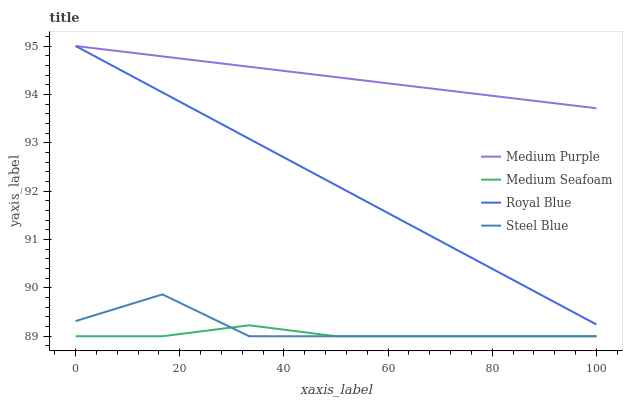Does Medium Seafoam have the minimum area under the curve?
Answer yes or no. Yes. Does Medium Purple have the maximum area under the curve?
Answer yes or no. Yes. Does Royal Blue have the minimum area under the curve?
Answer yes or no. No. Does Royal Blue have the maximum area under the curve?
Answer yes or no. No. Is Royal Blue the smoothest?
Answer yes or no. Yes. Is Steel Blue the roughest?
Answer yes or no. Yes. Is Medium Seafoam the smoothest?
Answer yes or no. No. Is Medium Seafoam the roughest?
Answer yes or no. No. Does Medium Seafoam have the lowest value?
Answer yes or no. Yes. Does Royal Blue have the lowest value?
Answer yes or no. No. Does Royal Blue have the highest value?
Answer yes or no. Yes. Does Medium Seafoam have the highest value?
Answer yes or no. No. Is Steel Blue less than Medium Purple?
Answer yes or no. Yes. Is Royal Blue greater than Medium Seafoam?
Answer yes or no. Yes. Does Medium Seafoam intersect Steel Blue?
Answer yes or no. Yes. Is Medium Seafoam less than Steel Blue?
Answer yes or no. No. Is Medium Seafoam greater than Steel Blue?
Answer yes or no. No. Does Steel Blue intersect Medium Purple?
Answer yes or no. No. 